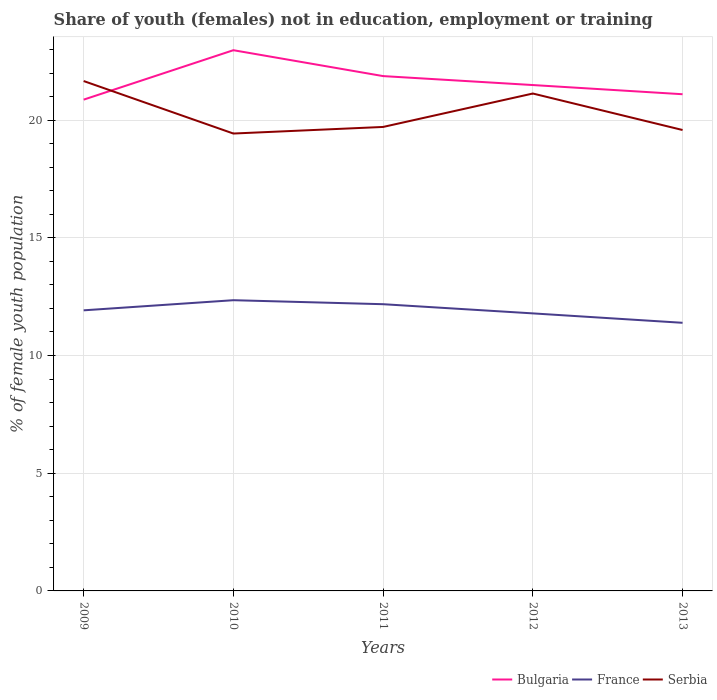Does the line corresponding to France intersect with the line corresponding to Bulgaria?
Provide a short and direct response. No. Across all years, what is the maximum percentage of unemployed female population in in France?
Provide a short and direct response. 11.39. In which year was the percentage of unemployed female population in in France maximum?
Your response must be concise. 2013. What is the total percentage of unemployed female population in in France in the graph?
Your response must be concise. 0.4. What is the difference between the highest and the second highest percentage of unemployed female population in in France?
Keep it short and to the point. 0.96. Where does the legend appear in the graph?
Make the answer very short. Bottom right. How are the legend labels stacked?
Provide a short and direct response. Horizontal. What is the title of the graph?
Offer a very short reply. Share of youth (females) not in education, employment or training. Does "Russian Federation" appear as one of the legend labels in the graph?
Your response must be concise. No. What is the label or title of the Y-axis?
Give a very brief answer. % of female youth population. What is the % of female youth population in Bulgaria in 2009?
Ensure brevity in your answer.  20.87. What is the % of female youth population in France in 2009?
Provide a succinct answer. 11.92. What is the % of female youth population in Serbia in 2009?
Your answer should be compact. 21.66. What is the % of female youth population in Bulgaria in 2010?
Keep it short and to the point. 22.97. What is the % of female youth population of France in 2010?
Ensure brevity in your answer.  12.35. What is the % of female youth population of Serbia in 2010?
Ensure brevity in your answer.  19.43. What is the % of female youth population in Bulgaria in 2011?
Provide a succinct answer. 21.87. What is the % of female youth population of France in 2011?
Offer a terse response. 12.18. What is the % of female youth population of Serbia in 2011?
Ensure brevity in your answer.  19.71. What is the % of female youth population in Bulgaria in 2012?
Make the answer very short. 21.49. What is the % of female youth population in France in 2012?
Make the answer very short. 11.79. What is the % of female youth population in Serbia in 2012?
Ensure brevity in your answer.  21.13. What is the % of female youth population of Bulgaria in 2013?
Keep it short and to the point. 21.1. What is the % of female youth population of France in 2013?
Offer a terse response. 11.39. What is the % of female youth population in Serbia in 2013?
Your response must be concise. 19.58. Across all years, what is the maximum % of female youth population of Bulgaria?
Give a very brief answer. 22.97. Across all years, what is the maximum % of female youth population of France?
Keep it short and to the point. 12.35. Across all years, what is the maximum % of female youth population in Serbia?
Your answer should be compact. 21.66. Across all years, what is the minimum % of female youth population in Bulgaria?
Your answer should be compact. 20.87. Across all years, what is the minimum % of female youth population in France?
Make the answer very short. 11.39. Across all years, what is the minimum % of female youth population of Serbia?
Your response must be concise. 19.43. What is the total % of female youth population in Bulgaria in the graph?
Make the answer very short. 108.3. What is the total % of female youth population in France in the graph?
Offer a terse response. 59.63. What is the total % of female youth population in Serbia in the graph?
Your response must be concise. 101.51. What is the difference between the % of female youth population of Bulgaria in 2009 and that in 2010?
Offer a terse response. -2.1. What is the difference between the % of female youth population in France in 2009 and that in 2010?
Ensure brevity in your answer.  -0.43. What is the difference between the % of female youth population of Serbia in 2009 and that in 2010?
Your response must be concise. 2.23. What is the difference between the % of female youth population in Bulgaria in 2009 and that in 2011?
Your answer should be compact. -1. What is the difference between the % of female youth population of France in 2009 and that in 2011?
Offer a terse response. -0.26. What is the difference between the % of female youth population in Serbia in 2009 and that in 2011?
Your answer should be very brief. 1.95. What is the difference between the % of female youth population of Bulgaria in 2009 and that in 2012?
Ensure brevity in your answer.  -0.62. What is the difference between the % of female youth population of France in 2009 and that in 2012?
Offer a terse response. 0.13. What is the difference between the % of female youth population in Serbia in 2009 and that in 2012?
Your answer should be very brief. 0.53. What is the difference between the % of female youth population of Bulgaria in 2009 and that in 2013?
Give a very brief answer. -0.23. What is the difference between the % of female youth population of France in 2009 and that in 2013?
Keep it short and to the point. 0.53. What is the difference between the % of female youth population of Serbia in 2009 and that in 2013?
Your answer should be compact. 2.08. What is the difference between the % of female youth population in Bulgaria in 2010 and that in 2011?
Make the answer very short. 1.1. What is the difference between the % of female youth population in France in 2010 and that in 2011?
Offer a terse response. 0.17. What is the difference between the % of female youth population in Serbia in 2010 and that in 2011?
Offer a very short reply. -0.28. What is the difference between the % of female youth population in Bulgaria in 2010 and that in 2012?
Your answer should be compact. 1.48. What is the difference between the % of female youth population in France in 2010 and that in 2012?
Your answer should be compact. 0.56. What is the difference between the % of female youth population of Bulgaria in 2010 and that in 2013?
Your answer should be very brief. 1.87. What is the difference between the % of female youth population of Serbia in 2010 and that in 2013?
Keep it short and to the point. -0.15. What is the difference between the % of female youth population in Bulgaria in 2011 and that in 2012?
Keep it short and to the point. 0.38. What is the difference between the % of female youth population in France in 2011 and that in 2012?
Your answer should be compact. 0.39. What is the difference between the % of female youth population in Serbia in 2011 and that in 2012?
Ensure brevity in your answer.  -1.42. What is the difference between the % of female youth population of Bulgaria in 2011 and that in 2013?
Make the answer very short. 0.77. What is the difference between the % of female youth population of France in 2011 and that in 2013?
Your response must be concise. 0.79. What is the difference between the % of female youth population of Serbia in 2011 and that in 2013?
Your answer should be compact. 0.13. What is the difference between the % of female youth population in Bulgaria in 2012 and that in 2013?
Provide a succinct answer. 0.39. What is the difference between the % of female youth population of Serbia in 2012 and that in 2013?
Keep it short and to the point. 1.55. What is the difference between the % of female youth population in Bulgaria in 2009 and the % of female youth population in France in 2010?
Your answer should be compact. 8.52. What is the difference between the % of female youth population of Bulgaria in 2009 and the % of female youth population of Serbia in 2010?
Give a very brief answer. 1.44. What is the difference between the % of female youth population in France in 2009 and the % of female youth population in Serbia in 2010?
Keep it short and to the point. -7.51. What is the difference between the % of female youth population in Bulgaria in 2009 and the % of female youth population in France in 2011?
Provide a succinct answer. 8.69. What is the difference between the % of female youth population of Bulgaria in 2009 and the % of female youth population of Serbia in 2011?
Your answer should be compact. 1.16. What is the difference between the % of female youth population of France in 2009 and the % of female youth population of Serbia in 2011?
Provide a succinct answer. -7.79. What is the difference between the % of female youth population of Bulgaria in 2009 and the % of female youth population of France in 2012?
Your answer should be very brief. 9.08. What is the difference between the % of female youth population of Bulgaria in 2009 and the % of female youth population of Serbia in 2012?
Provide a succinct answer. -0.26. What is the difference between the % of female youth population of France in 2009 and the % of female youth population of Serbia in 2012?
Keep it short and to the point. -9.21. What is the difference between the % of female youth population in Bulgaria in 2009 and the % of female youth population in France in 2013?
Your response must be concise. 9.48. What is the difference between the % of female youth population of Bulgaria in 2009 and the % of female youth population of Serbia in 2013?
Your response must be concise. 1.29. What is the difference between the % of female youth population of France in 2009 and the % of female youth population of Serbia in 2013?
Your answer should be compact. -7.66. What is the difference between the % of female youth population in Bulgaria in 2010 and the % of female youth population in France in 2011?
Keep it short and to the point. 10.79. What is the difference between the % of female youth population in Bulgaria in 2010 and the % of female youth population in Serbia in 2011?
Your answer should be compact. 3.26. What is the difference between the % of female youth population of France in 2010 and the % of female youth population of Serbia in 2011?
Keep it short and to the point. -7.36. What is the difference between the % of female youth population of Bulgaria in 2010 and the % of female youth population of France in 2012?
Ensure brevity in your answer.  11.18. What is the difference between the % of female youth population in Bulgaria in 2010 and the % of female youth population in Serbia in 2012?
Give a very brief answer. 1.84. What is the difference between the % of female youth population in France in 2010 and the % of female youth population in Serbia in 2012?
Offer a very short reply. -8.78. What is the difference between the % of female youth population of Bulgaria in 2010 and the % of female youth population of France in 2013?
Make the answer very short. 11.58. What is the difference between the % of female youth population of Bulgaria in 2010 and the % of female youth population of Serbia in 2013?
Your answer should be very brief. 3.39. What is the difference between the % of female youth population in France in 2010 and the % of female youth population in Serbia in 2013?
Provide a succinct answer. -7.23. What is the difference between the % of female youth population of Bulgaria in 2011 and the % of female youth population of France in 2012?
Your response must be concise. 10.08. What is the difference between the % of female youth population of Bulgaria in 2011 and the % of female youth population of Serbia in 2012?
Your answer should be very brief. 0.74. What is the difference between the % of female youth population in France in 2011 and the % of female youth population in Serbia in 2012?
Your response must be concise. -8.95. What is the difference between the % of female youth population of Bulgaria in 2011 and the % of female youth population of France in 2013?
Your response must be concise. 10.48. What is the difference between the % of female youth population in Bulgaria in 2011 and the % of female youth population in Serbia in 2013?
Your response must be concise. 2.29. What is the difference between the % of female youth population in France in 2011 and the % of female youth population in Serbia in 2013?
Your answer should be compact. -7.4. What is the difference between the % of female youth population of Bulgaria in 2012 and the % of female youth population of Serbia in 2013?
Keep it short and to the point. 1.91. What is the difference between the % of female youth population of France in 2012 and the % of female youth population of Serbia in 2013?
Offer a very short reply. -7.79. What is the average % of female youth population of Bulgaria per year?
Make the answer very short. 21.66. What is the average % of female youth population of France per year?
Make the answer very short. 11.93. What is the average % of female youth population in Serbia per year?
Your response must be concise. 20.3. In the year 2009, what is the difference between the % of female youth population in Bulgaria and % of female youth population in France?
Keep it short and to the point. 8.95. In the year 2009, what is the difference between the % of female youth population of Bulgaria and % of female youth population of Serbia?
Provide a short and direct response. -0.79. In the year 2009, what is the difference between the % of female youth population in France and % of female youth population in Serbia?
Offer a terse response. -9.74. In the year 2010, what is the difference between the % of female youth population in Bulgaria and % of female youth population in France?
Your answer should be compact. 10.62. In the year 2010, what is the difference between the % of female youth population in Bulgaria and % of female youth population in Serbia?
Your response must be concise. 3.54. In the year 2010, what is the difference between the % of female youth population in France and % of female youth population in Serbia?
Your response must be concise. -7.08. In the year 2011, what is the difference between the % of female youth population in Bulgaria and % of female youth population in France?
Provide a short and direct response. 9.69. In the year 2011, what is the difference between the % of female youth population in Bulgaria and % of female youth population in Serbia?
Offer a terse response. 2.16. In the year 2011, what is the difference between the % of female youth population of France and % of female youth population of Serbia?
Provide a succinct answer. -7.53. In the year 2012, what is the difference between the % of female youth population in Bulgaria and % of female youth population in France?
Provide a short and direct response. 9.7. In the year 2012, what is the difference between the % of female youth population in Bulgaria and % of female youth population in Serbia?
Provide a succinct answer. 0.36. In the year 2012, what is the difference between the % of female youth population in France and % of female youth population in Serbia?
Offer a terse response. -9.34. In the year 2013, what is the difference between the % of female youth population in Bulgaria and % of female youth population in France?
Provide a succinct answer. 9.71. In the year 2013, what is the difference between the % of female youth population of Bulgaria and % of female youth population of Serbia?
Provide a succinct answer. 1.52. In the year 2013, what is the difference between the % of female youth population of France and % of female youth population of Serbia?
Keep it short and to the point. -8.19. What is the ratio of the % of female youth population of Bulgaria in 2009 to that in 2010?
Your response must be concise. 0.91. What is the ratio of the % of female youth population in France in 2009 to that in 2010?
Provide a short and direct response. 0.97. What is the ratio of the % of female youth population in Serbia in 2009 to that in 2010?
Offer a terse response. 1.11. What is the ratio of the % of female youth population of Bulgaria in 2009 to that in 2011?
Ensure brevity in your answer.  0.95. What is the ratio of the % of female youth population of France in 2009 to that in 2011?
Make the answer very short. 0.98. What is the ratio of the % of female youth population in Serbia in 2009 to that in 2011?
Give a very brief answer. 1.1. What is the ratio of the % of female youth population in Bulgaria in 2009 to that in 2012?
Offer a very short reply. 0.97. What is the ratio of the % of female youth population of Serbia in 2009 to that in 2012?
Provide a short and direct response. 1.03. What is the ratio of the % of female youth population of France in 2009 to that in 2013?
Give a very brief answer. 1.05. What is the ratio of the % of female youth population of Serbia in 2009 to that in 2013?
Provide a short and direct response. 1.11. What is the ratio of the % of female youth population in Bulgaria in 2010 to that in 2011?
Ensure brevity in your answer.  1.05. What is the ratio of the % of female youth population in Serbia in 2010 to that in 2011?
Offer a terse response. 0.99. What is the ratio of the % of female youth population of Bulgaria in 2010 to that in 2012?
Provide a succinct answer. 1.07. What is the ratio of the % of female youth population in France in 2010 to that in 2012?
Give a very brief answer. 1.05. What is the ratio of the % of female youth population in Serbia in 2010 to that in 2012?
Provide a short and direct response. 0.92. What is the ratio of the % of female youth population in Bulgaria in 2010 to that in 2013?
Make the answer very short. 1.09. What is the ratio of the % of female youth population in France in 2010 to that in 2013?
Offer a very short reply. 1.08. What is the ratio of the % of female youth population of Serbia in 2010 to that in 2013?
Make the answer very short. 0.99. What is the ratio of the % of female youth population of Bulgaria in 2011 to that in 2012?
Keep it short and to the point. 1.02. What is the ratio of the % of female youth population of France in 2011 to that in 2012?
Provide a short and direct response. 1.03. What is the ratio of the % of female youth population of Serbia in 2011 to that in 2012?
Your response must be concise. 0.93. What is the ratio of the % of female youth population of Bulgaria in 2011 to that in 2013?
Keep it short and to the point. 1.04. What is the ratio of the % of female youth population in France in 2011 to that in 2013?
Give a very brief answer. 1.07. What is the ratio of the % of female youth population in Serbia in 2011 to that in 2013?
Provide a short and direct response. 1.01. What is the ratio of the % of female youth population of Bulgaria in 2012 to that in 2013?
Offer a very short reply. 1.02. What is the ratio of the % of female youth population of France in 2012 to that in 2013?
Keep it short and to the point. 1.04. What is the ratio of the % of female youth population of Serbia in 2012 to that in 2013?
Make the answer very short. 1.08. What is the difference between the highest and the second highest % of female youth population of France?
Make the answer very short. 0.17. What is the difference between the highest and the second highest % of female youth population of Serbia?
Offer a very short reply. 0.53. What is the difference between the highest and the lowest % of female youth population of Bulgaria?
Provide a succinct answer. 2.1. What is the difference between the highest and the lowest % of female youth population in France?
Offer a terse response. 0.96. What is the difference between the highest and the lowest % of female youth population of Serbia?
Provide a short and direct response. 2.23. 